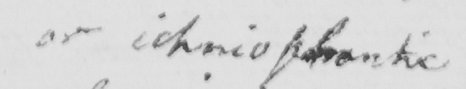What text is written in this handwritten line? or ichniophantic 